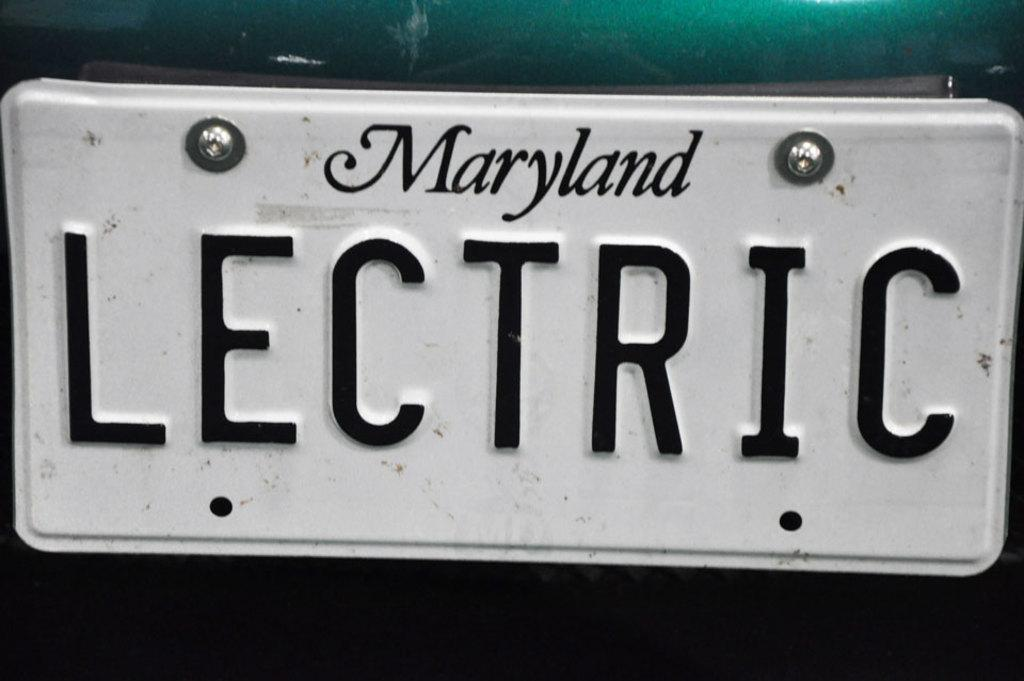What can be found on the number plate in the image? There is text on a number plate in the image. What is the purpose of the number plate? The number plate is associated with a vehicle. Can you see any trains on the hill in the image? There is no hill or train present in the image. 